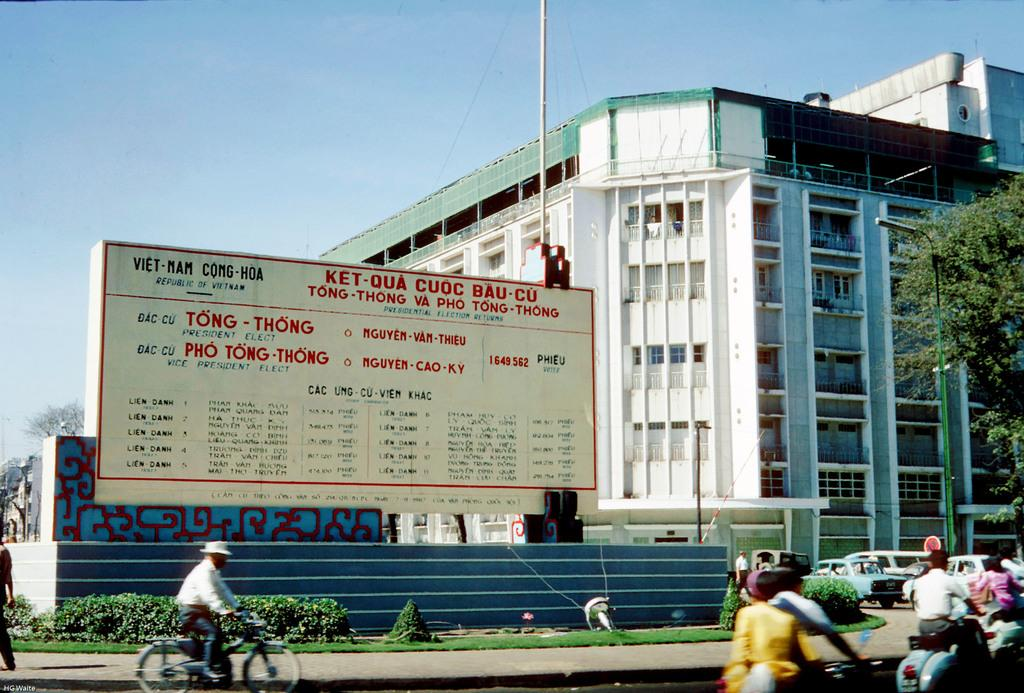How many people are in the image? There is a group of people in the image, but the exact number cannot be determined from the provided facts. What can be seen in the background of the image? There is a building, trees, the sky, and a street light visible in the background of the image. What type of creature is sitting on the kettle in the image? There is no kettle or creature present in the image. Can you tell me the color of the tiger in the image? There is no tiger present in the image. 